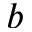<formula> <loc_0><loc_0><loc_500><loc_500>b</formula> 